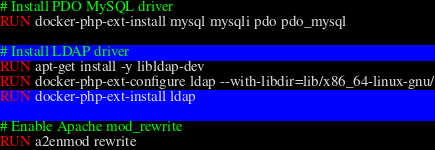Convert code to text. <code><loc_0><loc_0><loc_500><loc_500><_Dockerfile_>
# Install PDO MySQL driver
RUN docker-php-ext-install mysql mysqli pdo pdo_mysql

# Install LDAP driver
RUN apt-get install -y libldap-dev
RUN docker-php-ext-configure ldap --with-libdir=lib/x86_64-linux-gnu/
RUN docker-php-ext-install ldap

# Enable Apache mod_rewrite
RUN a2enmod rewrite</code> 